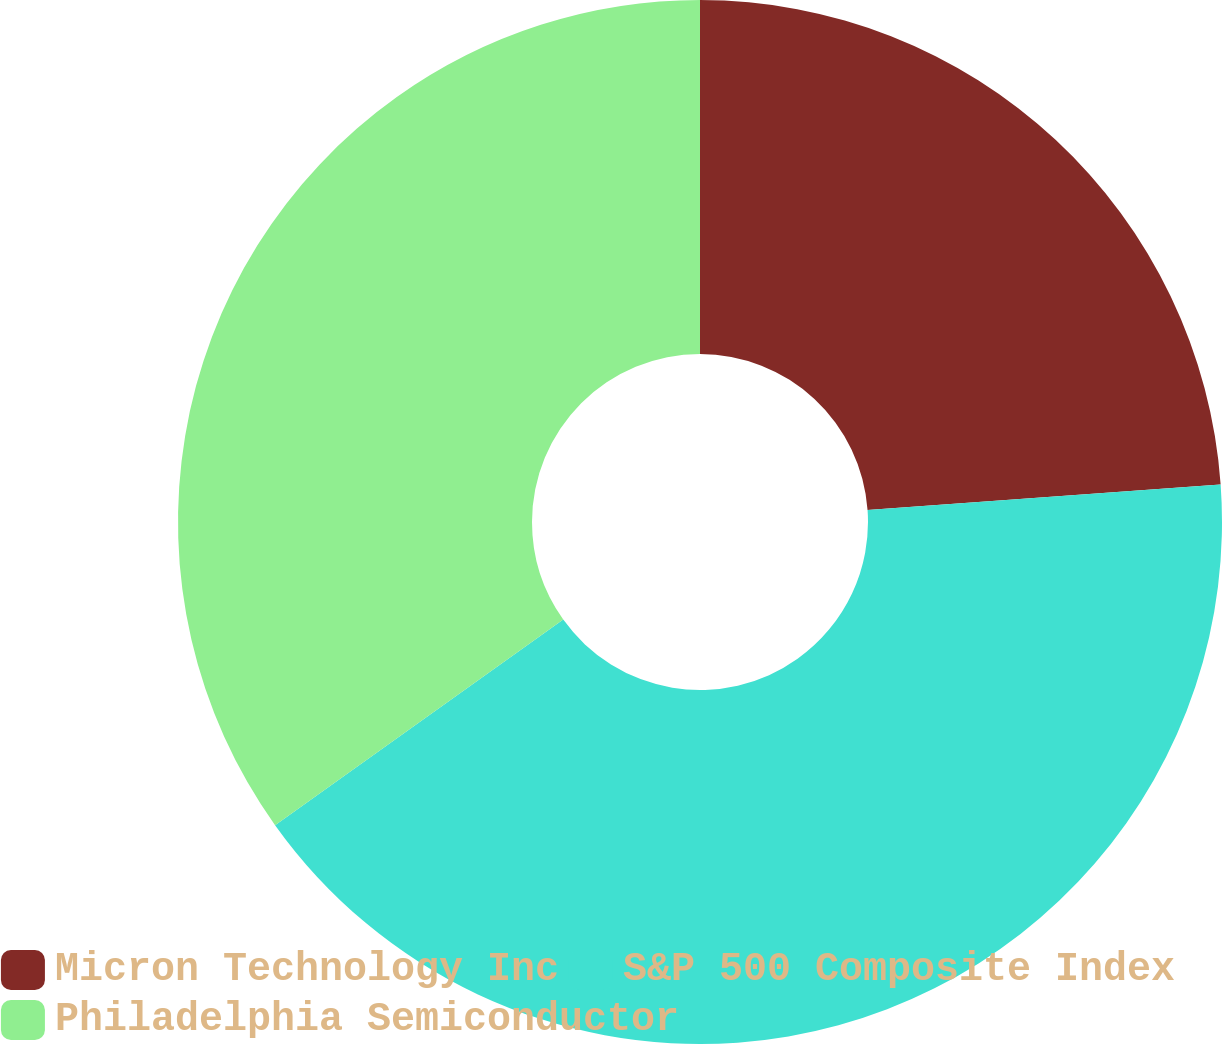Convert chart. <chart><loc_0><loc_0><loc_500><loc_500><pie_chart><fcel>Micron Technology Inc<fcel>S&P 500 Composite Index<fcel>Philadelphia Semiconductor<nl><fcel>23.85%<fcel>41.28%<fcel>34.86%<nl></chart> 